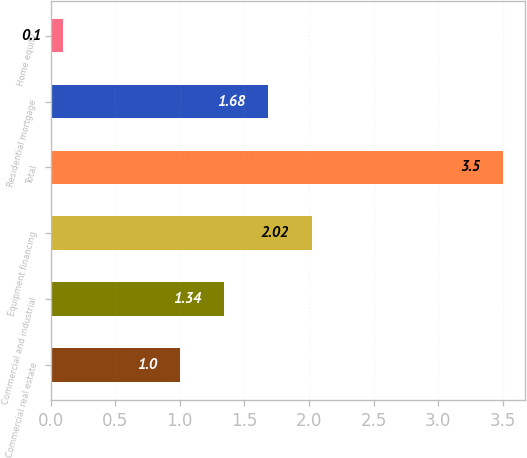Convert chart to OTSL. <chart><loc_0><loc_0><loc_500><loc_500><bar_chart><fcel>Commercial real estate<fcel>Commercial and industrial<fcel>Equipment financing<fcel>Total<fcel>Residential mortgage<fcel>Home equity<nl><fcel>1<fcel>1.34<fcel>2.02<fcel>3.5<fcel>1.68<fcel>0.1<nl></chart> 